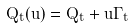<formula> <loc_0><loc_0><loc_500><loc_500>Q _ { t } ( u ) = Q _ { t } + u \Gamma _ { t }</formula> 